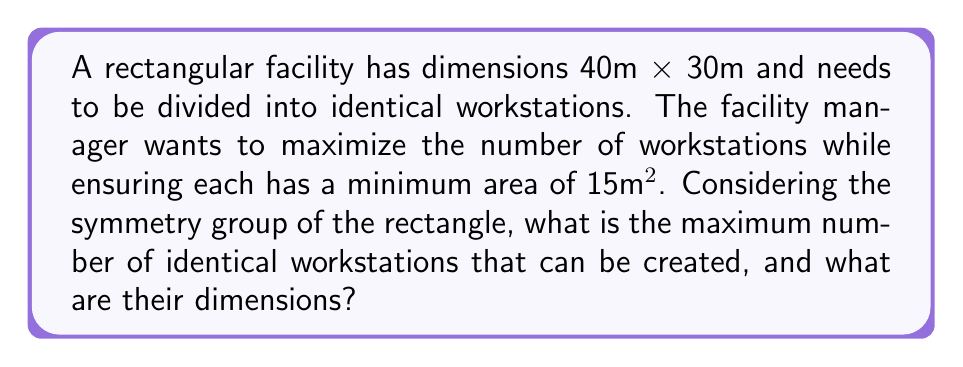What is the answer to this math problem? Let's approach this step-by-step:

1) The symmetry group of a rectangle includes rotations of 180° and two reflections (across vertical and horizontal axes). This means we can divide the space into identical parts that respect these symmetries.

2) The total area of the facility is:
   $$A_{total} = 40m \times 30m = 1200m²$$

3) Each workstation needs a minimum area of 15m². To maximize the number of workstations, we should aim for this minimum size.

4) The number of workstations (n) would be:
   $$n = \frac{A_{total}}{A_{workstation}} = \frac{1200}{15} = 80$$

5) However, we need to ensure that these 80 workstations can be arranged in a way that respects the rectangle's symmetry. The factors of 80 are: 1, 2, 4, 5, 8, 10, 16, 20, 40, 80.

6) We need to find a combination of these factors that fits into our 40m x 30m rectangle. The closest fit is 8 x 10 = 80.

7) This means we can divide the space into:
   - 8 sections along the 40m side: 40m ÷ 8 = 5m
   - 10 sections along the 30m side: 30m ÷ 10 = 3m

8) Each workstation would then have dimensions of 5m x 3m, with an area of:
   $$A_{workstation} = 5m \times 3m = 15m²$$

This arrangement respects the symmetry of the rectangle and meets the minimum area requirement for each workstation.
Answer: The maximum number of identical workstations is 80, each with dimensions of 5m x 3m. 